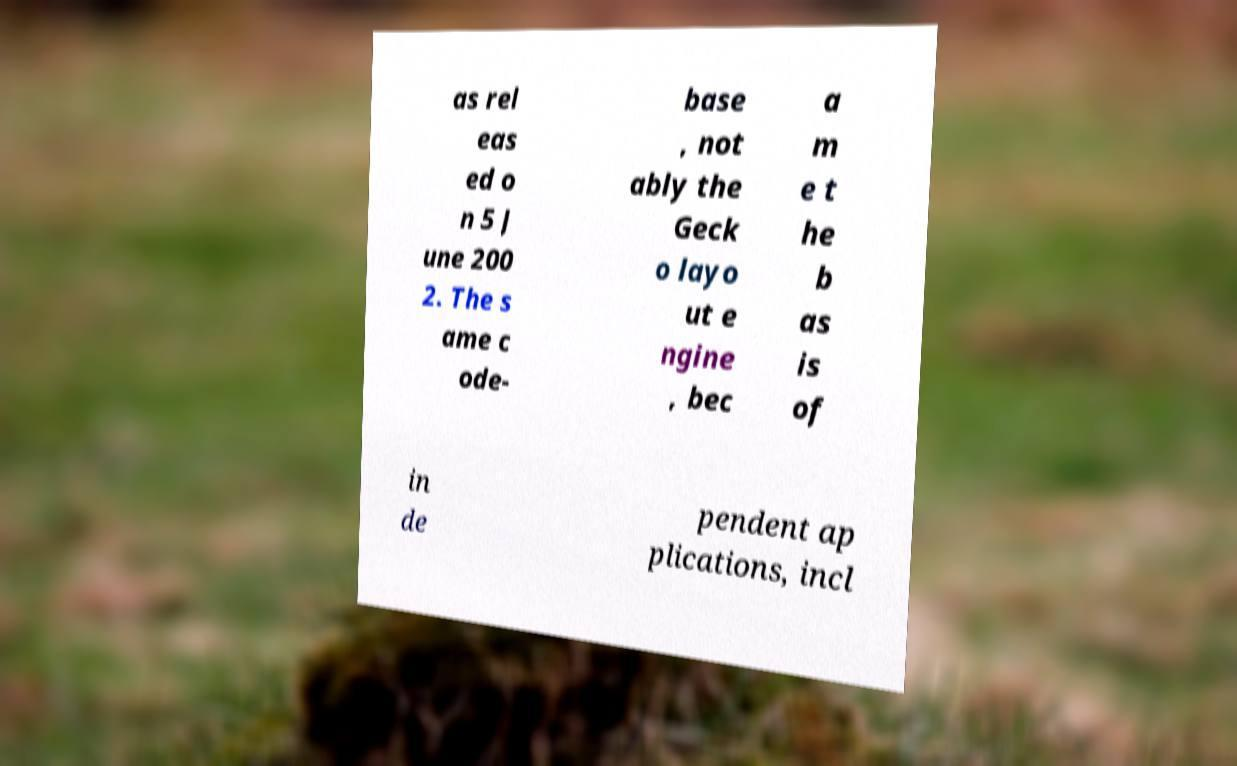Can you read and provide the text displayed in the image?This photo seems to have some interesting text. Can you extract and type it out for me? as rel eas ed o n 5 J une 200 2. The s ame c ode- base , not ably the Geck o layo ut e ngine , bec a m e t he b as is of in de pendent ap plications, incl 